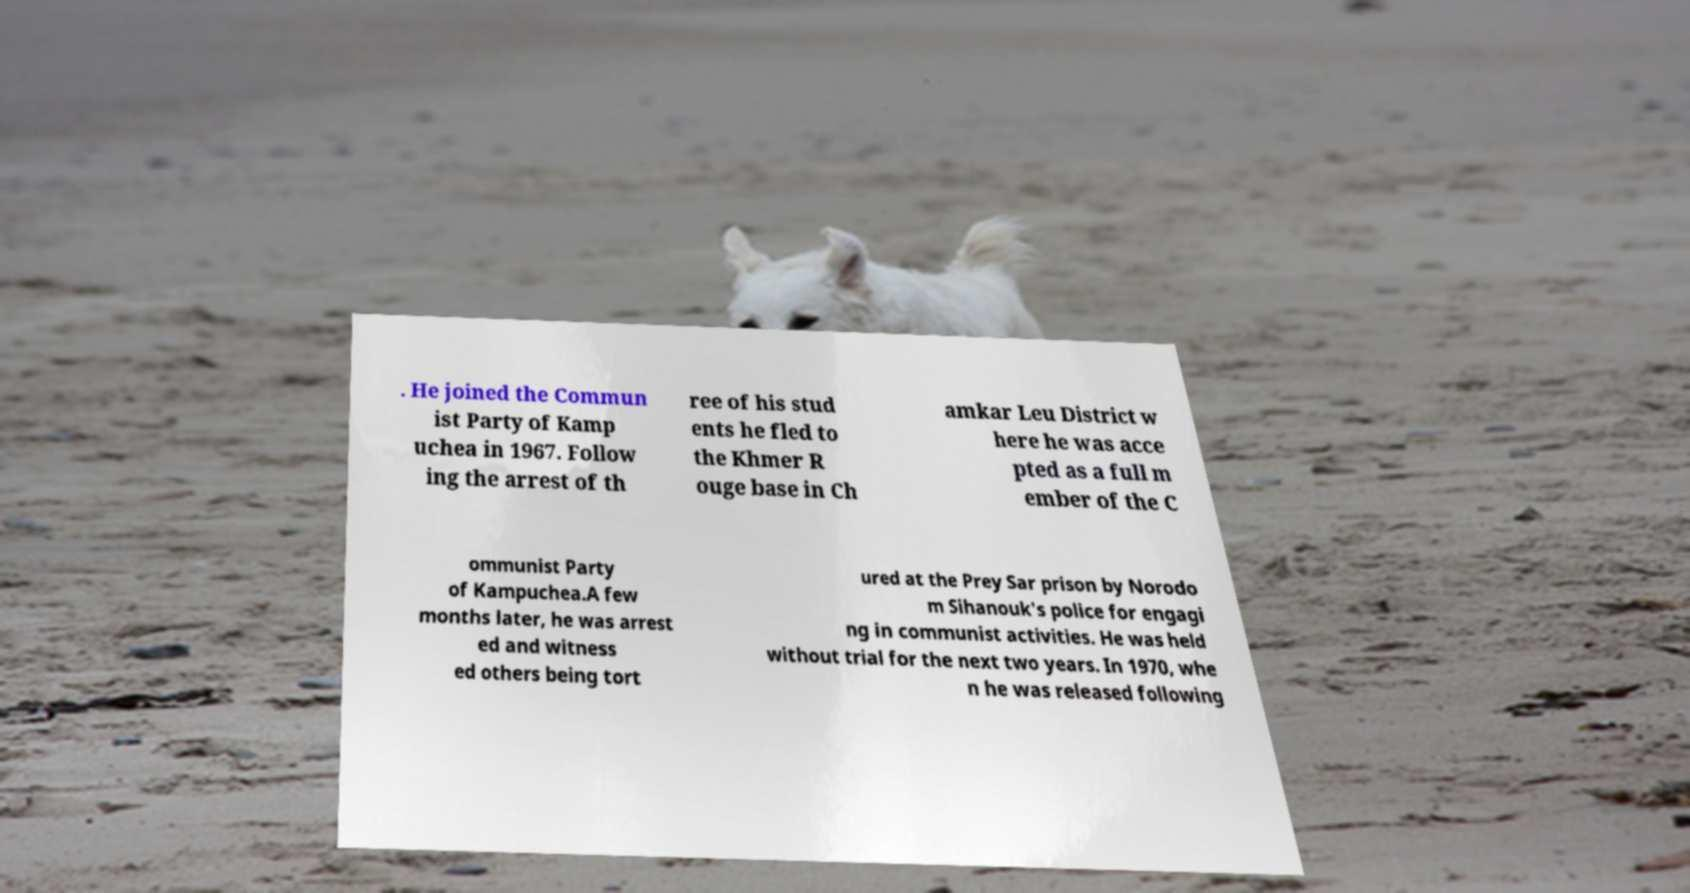Could you extract and type out the text from this image? . He joined the Commun ist Party of Kamp uchea in 1967. Follow ing the arrest of th ree of his stud ents he fled to the Khmer R ouge base in Ch amkar Leu District w here he was acce pted as a full m ember of the C ommunist Party of Kampuchea.A few months later, he was arrest ed and witness ed others being tort ured at the Prey Sar prison by Norodo m Sihanouk's police for engagi ng in communist activities. He was held without trial for the next two years. In 1970, whe n he was released following 